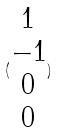<formula> <loc_0><loc_0><loc_500><loc_500>( \begin{matrix} 1 \\ - 1 \\ 0 \\ 0 \end{matrix} )</formula> 